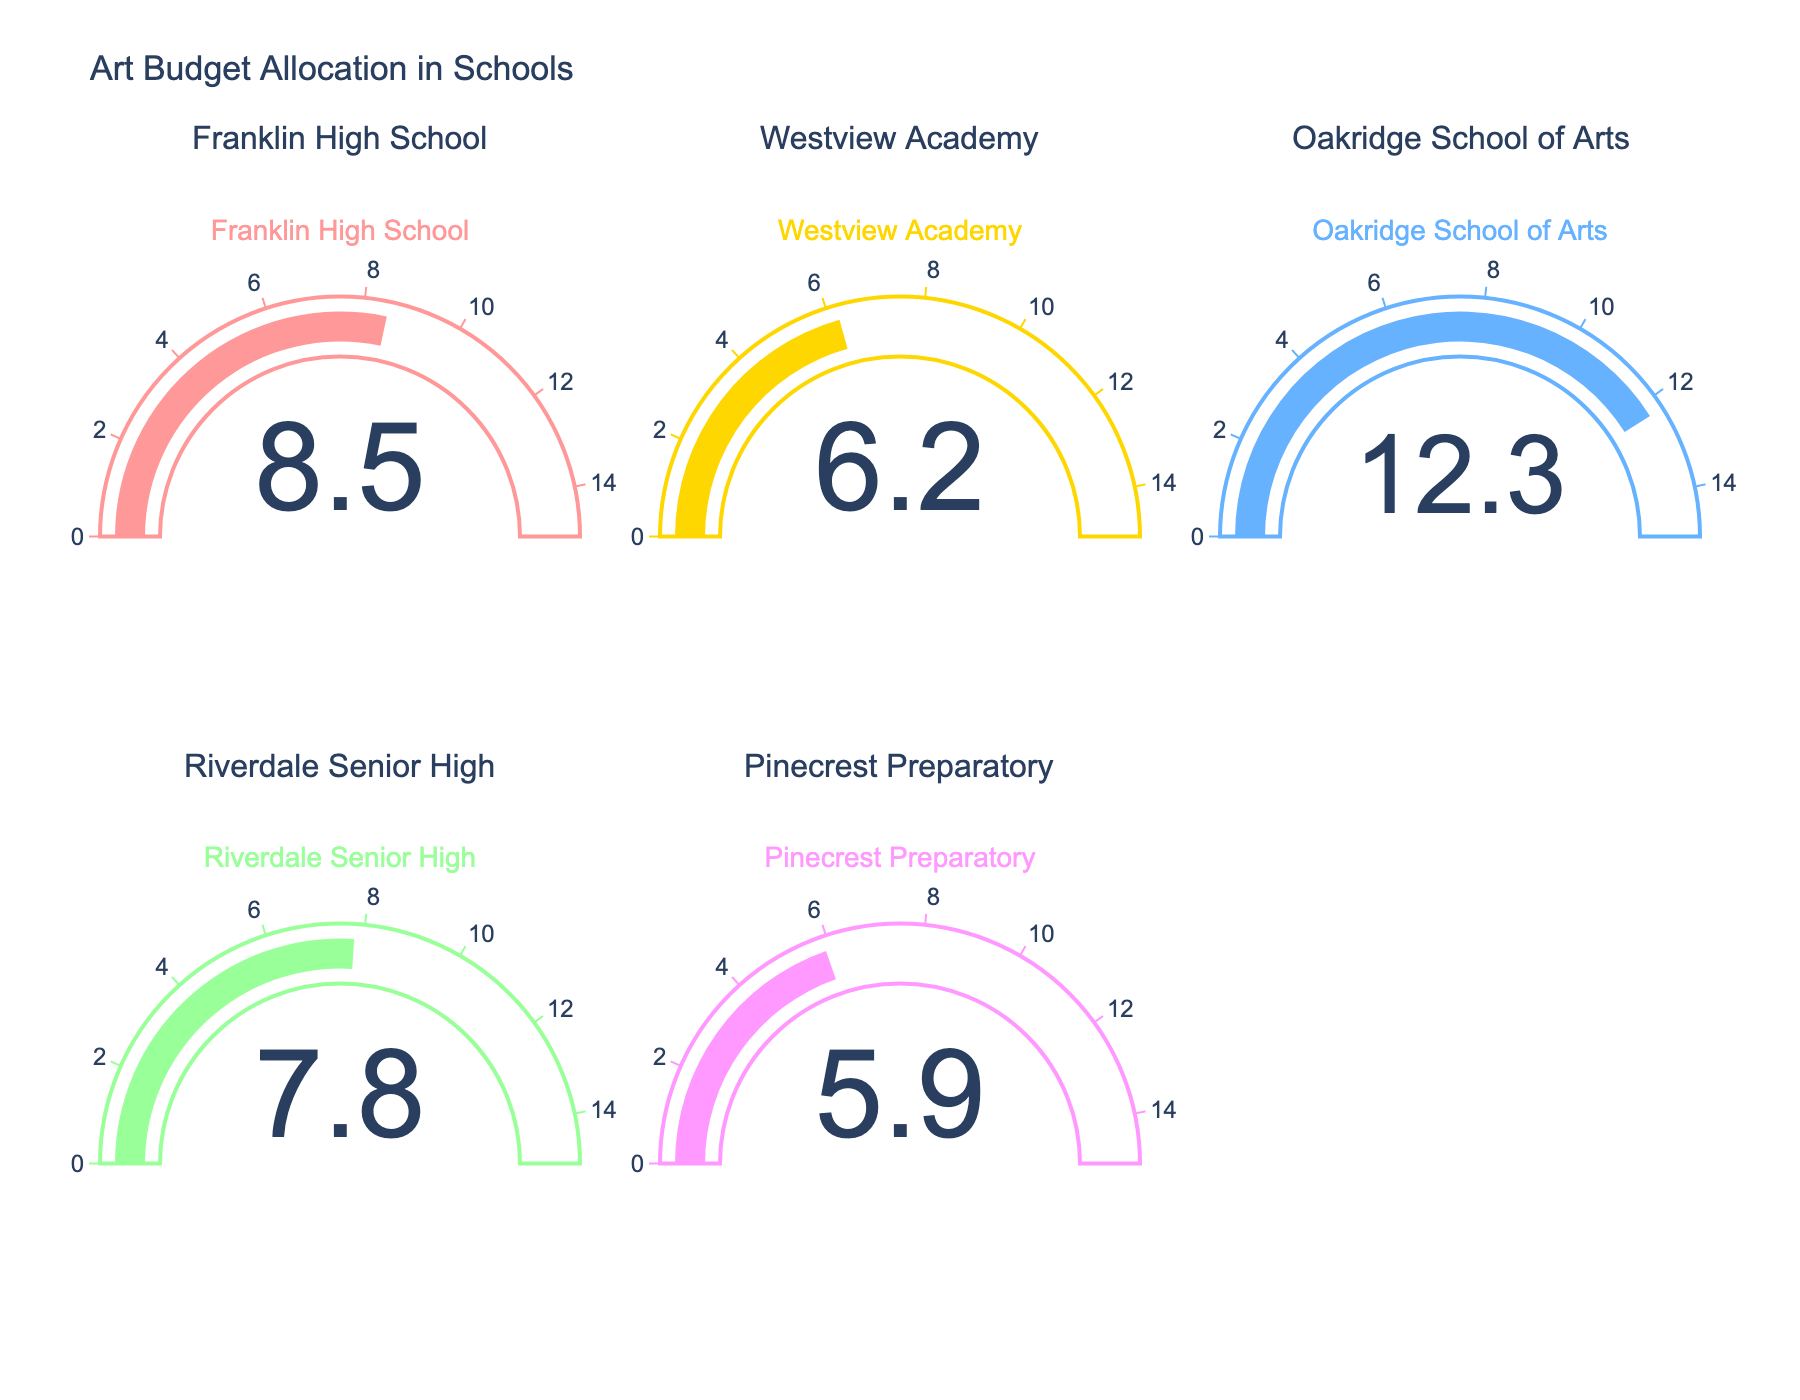what is the title of the figure? The title is usually displayed at the top of the figure, guiding the observer to understand what the plot is about.
Answer: Art Budget Allocation in Schools How many schools are represented in the figure? By examining the number of gauges, each representing a school, you can count the total number of schools shown in the figure.
Answer: 5 Which school allocates the highest percentage of its budget to art programs and supplies? By comparing the values displayed on each gauge, you can identify the highest percentage allocated to art programs. In this case, Oakridge School of Arts has the highest value of 12.3%.
Answer: Oakridge School of Arts Which school allocates the lowest percentage of its budget to art programs and supplies? By comparing the values on each gauge, you can identify the lowest percentage allocated to art programs. Pinecrest Preparatory has the lowest value of 5.9%.
Answer: Pinecrest Preparatory What is the total percentage allocated to art programs across all the schools? Sum the individual percentages displayed on each gauge: 8.5 + 6.2 + 12.3 + 7.8 + 5.9, which equals 40.7%.
Answer: 40.7 What is the average percentage allocation for art programs among the schools? The average can be calculated by dividing the total percentage by the number of schools: (8.5 + 6.2 + 12.3 + 7.8 + 5.9) / 5 = 40.7 / 5 = 8.14%.
Answer: 8.14 How much more percentage does Oakridge School of Arts allocate to art programs compared to Franklin High School? Subtract the percentage of Franklin High School from Oakridge School of Arts: 12.3 - 8.5 = 3.8%.
Answer: 3.8 Which school allocates more to art programs: Westview Academy or Pinecrest Preparatory? Compare the percentages on the gauges of the two schools: Westview Academy has 6.2% and Pinecrest Preparatory has 5.9%.
Answer: Westview Academy What's the range of art budget percentages among the schools? The range can be determined by subtracting the minimum percentage from the maximum percentage: 12.3 - 5.9 = 6.4%.
Answer: 6.4% 